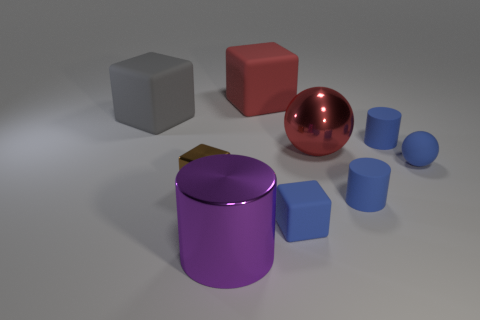Subtract all cyan spheres. Subtract all red blocks. How many spheres are left? 2 Add 1 tiny yellow cubes. How many objects exist? 10 Subtract all spheres. How many objects are left? 7 Add 4 small blue matte cubes. How many small blue matte cubes are left? 5 Add 3 blue matte objects. How many blue matte objects exist? 7 Subtract 1 gray blocks. How many objects are left? 8 Subtract all small matte cubes. Subtract all big matte objects. How many objects are left? 6 